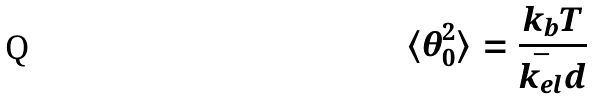<formula> <loc_0><loc_0><loc_500><loc_500>\langle \theta _ { 0 } ^ { 2 } \rangle = \frac { k _ { b } T } { \bar { k _ { e l } } d }</formula> 